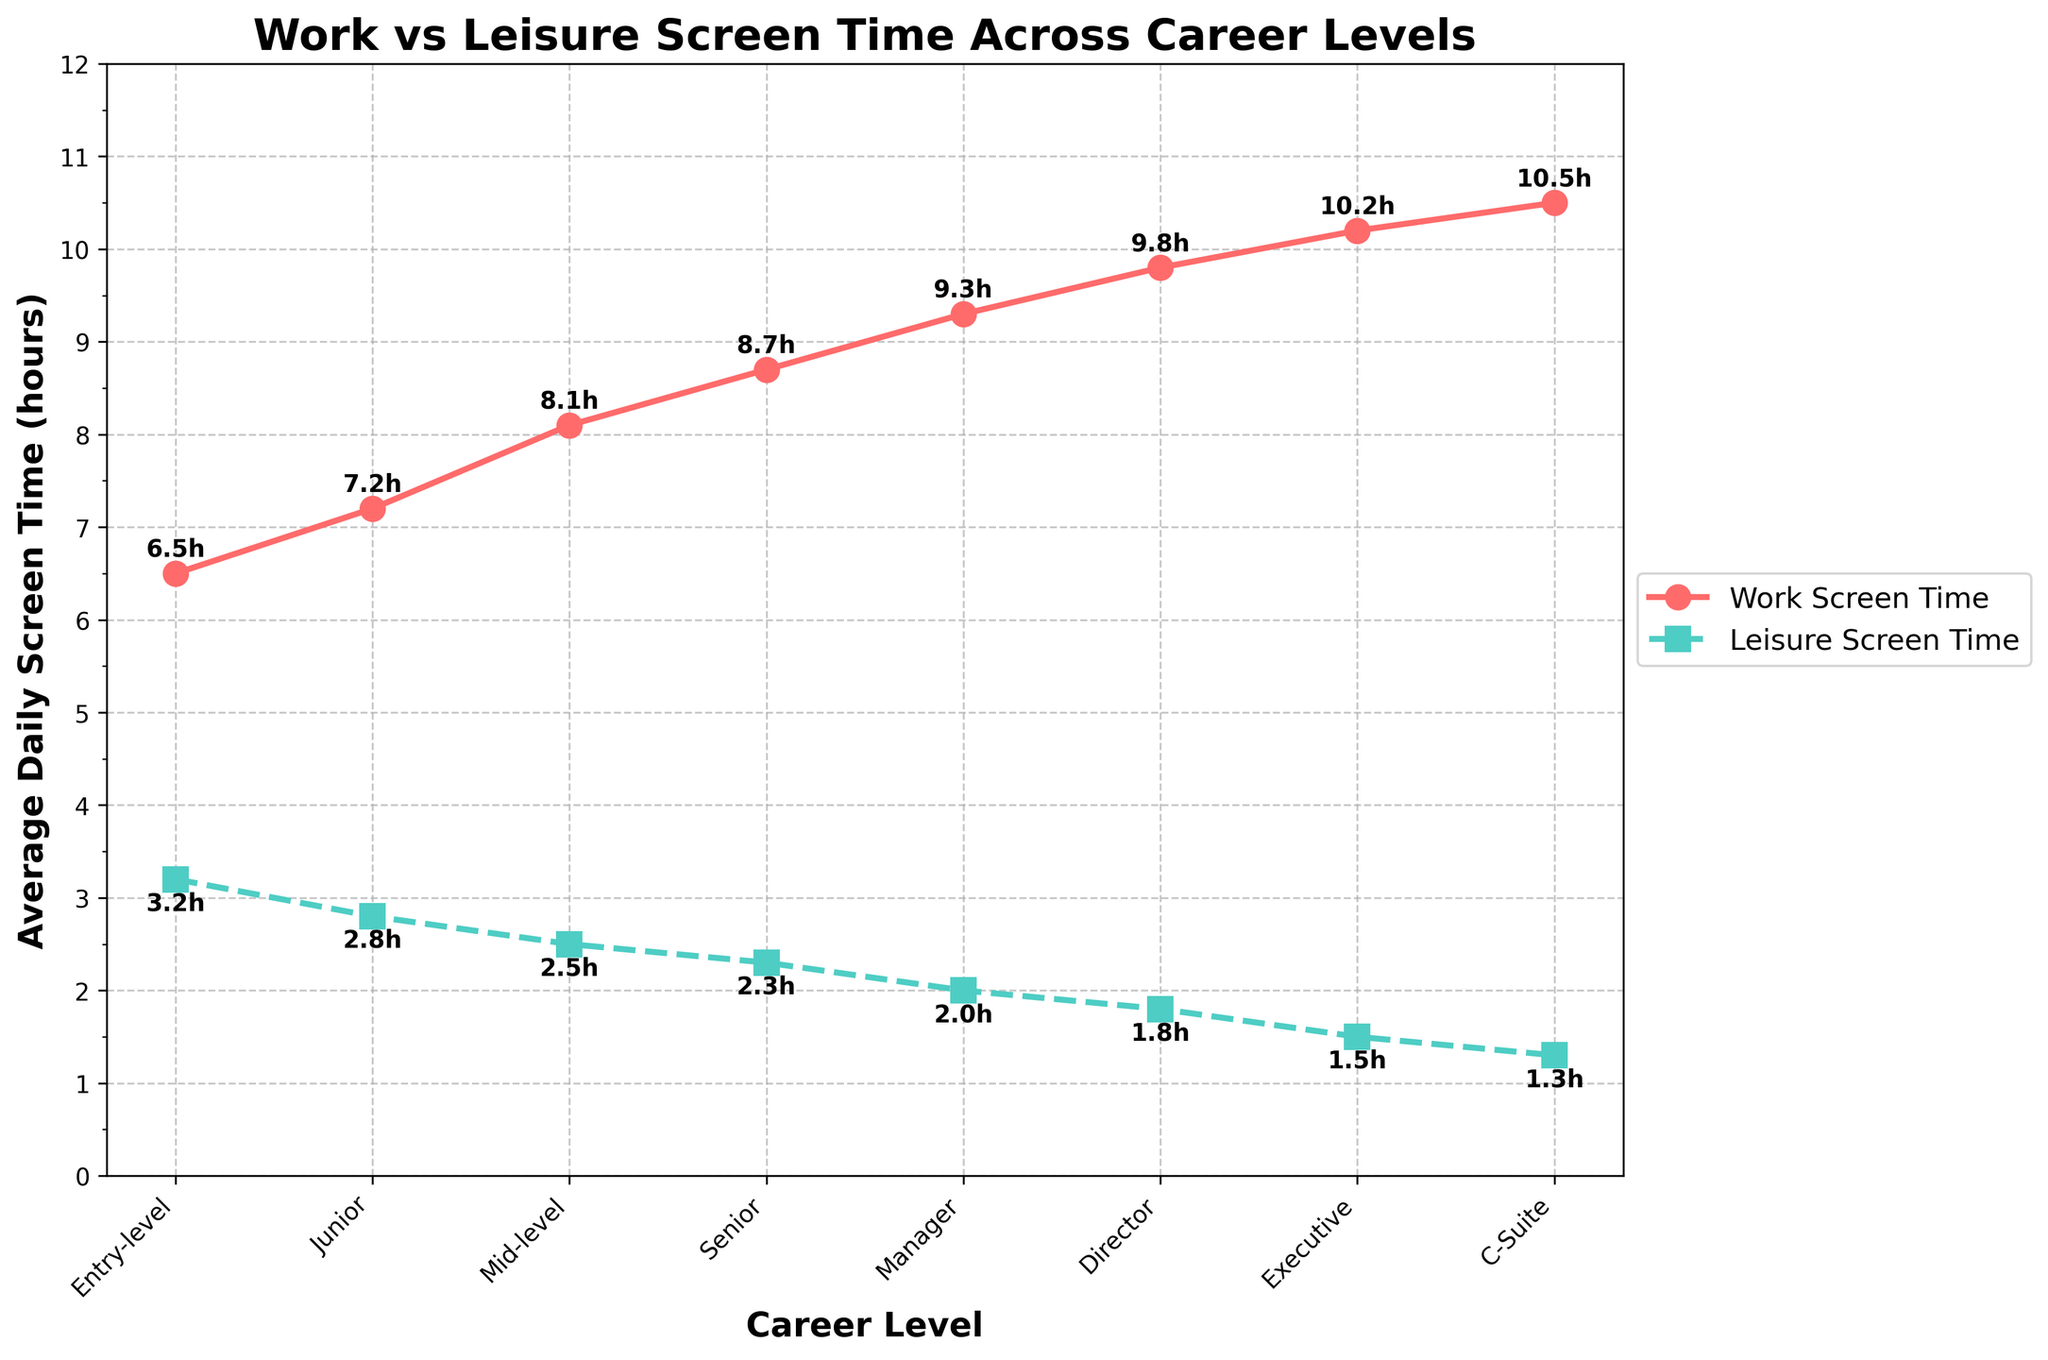What career level spends the least time on leisure screen activities? The C-Suite level has the lowest average daily leisure screen time, indicated by their position at the lowest point on the leisure screen time line (green line) in the graph.
Answer: C-Suite Which career level has the highest difference between work and leisure screen time? The Manager level has the highest difference between work and leisure screen time. This can be calculated as 9.3 hours (work) - 2.0 hours (leisure) = 7.3 hours, which is greater than the differences for other levels.
Answer: Manager Compare the trend of work screen time and leisure screen time across career levels. Work screen time increases progressively with each career level, while leisure screen time decreases. This can be seen from the upward slope of the red line and the downward slope of the green line respectively.
Answer: Work screen time increases, leisure screen time decreases What is the average work screen time for Mid-level, Senior, and Manager levels? Sum the work screen times: 8.1 (Mid-level) + 8.7 (Senior) + 9.3 (Manager) = 26.1 hours. The average is 26.1 / 3 = 8.7 hours.
Answer: 8.7 hours At which career level do work and leisure screen times differ by exactly 5 hours? The Mid-level has a work screen time of 8.1 hours and a leisure screen time of 2.5 hours. The difference is 8.1 - 2.5 = 5.6 hours.
Answer: Mid-level By how many hours does the work screen time of the Junior level exceed the leisure screen time of the same level? The Junior level has work screen time of 7.2 hours and leisure screen time of 2.8 hours. The difference is 7.2 - 2.8 = 4.4 hours.
Answer: 4.4 hours What is the combined total of leisure screen time for all career levels? Sum the leisure screen times: 3.2 + 2.8 + 2.5 + 2.3 + 2.0 + 1.8 + 1.5 + 1.3 = 17.4 hours.
Answer: 17.4 hours Which career level has the lowest difference between work and leisure screen time? The Entry-level has a work screen time of 6.5 hours and a leisure screen time of 3.2 hours. The difference is 6.5 - 3.2 = 3.3 hours, which is the smallest difference among all levels.
Answer: Entry-level 